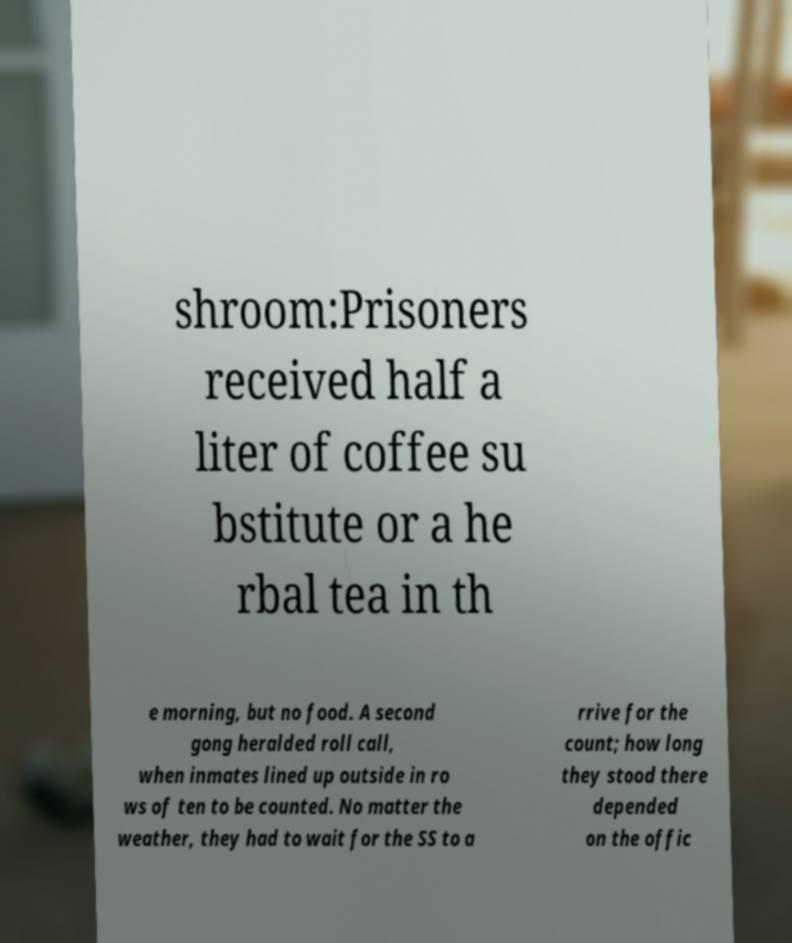Could you extract and type out the text from this image? shroom:Prisoners received half a liter of coffee su bstitute or a he rbal tea in th e morning, but no food. A second gong heralded roll call, when inmates lined up outside in ro ws of ten to be counted. No matter the weather, they had to wait for the SS to a rrive for the count; how long they stood there depended on the offic 